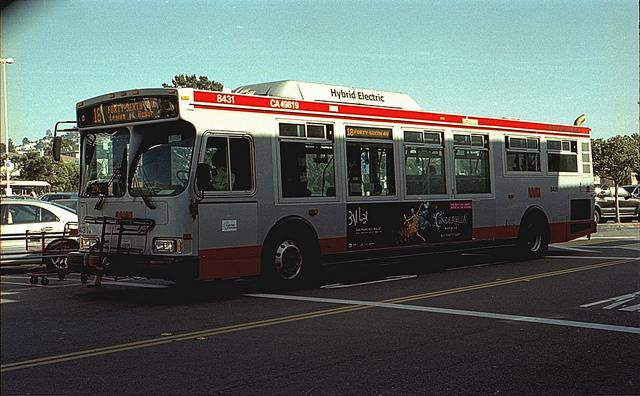How many wheels are visible on the large vehicle? two 